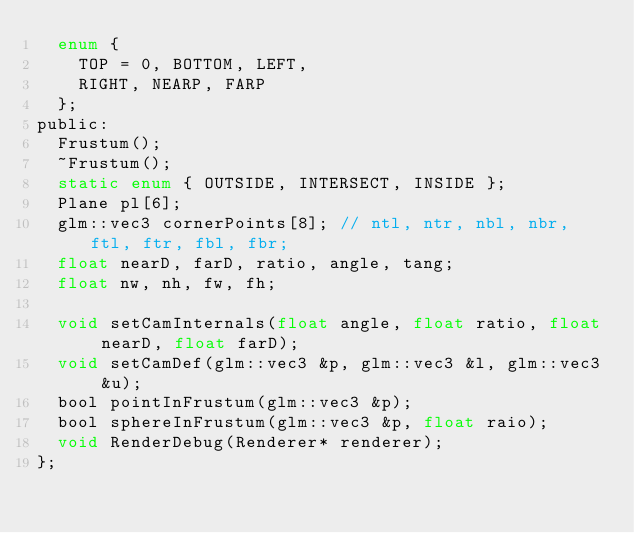<code> <loc_0><loc_0><loc_500><loc_500><_C_>	enum {
		TOP = 0, BOTTOM, LEFT,
		RIGHT, NEARP, FARP
	};
public:
	Frustum();
	~Frustum();
	static enum { OUTSIDE, INTERSECT, INSIDE };
	Plane pl[6];
	glm::vec3 cornerPoints[8]; // ntl, ntr, nbl, nbr, ftl, ftr, fbl, fbr;
	float nearD, farD, ratio, angle, tang;
	float nw, nh, fw, fh;

	void setCamInternals(float angle, float ratio, float nearD, float farD);
	void setCamDef(glm::vec3 &p, glm::vec3 &l, glm::vec3 &u);
	bool pointInFrustum(glm::vec3 &p);
	bool sphereInFrustum(glm::vec3 &p, float raio);
	void RenderDebug(Renderer* renderer);
};
</code> 